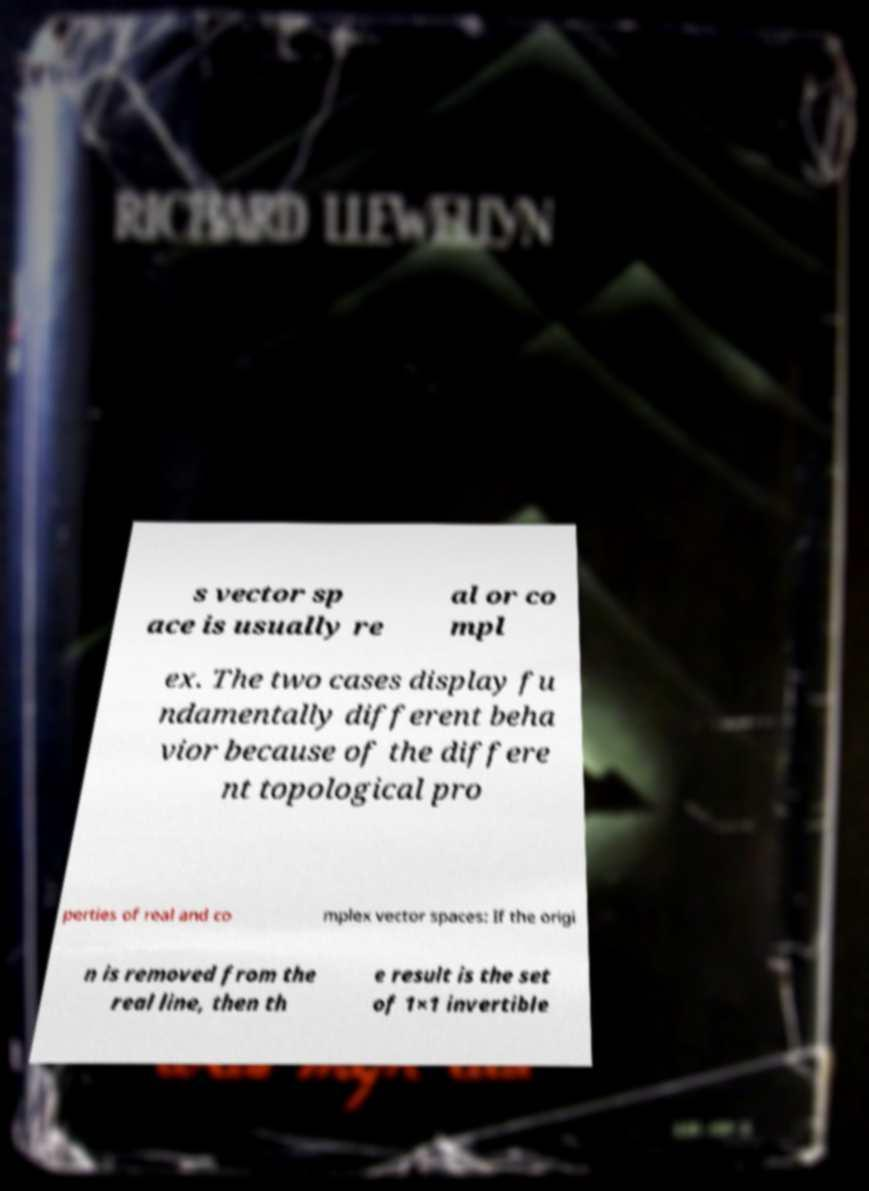I need the written content from this picture converted into text. Can you do that? s vector sp ace is usually re al or co mpl ex. The two cases display fu ndamentally different beha vior because of the differe nt topological pro perties of real and co mplex vector spaces: If the origi n is removed from the real line, then th e result is the set of 1×1 invertible 